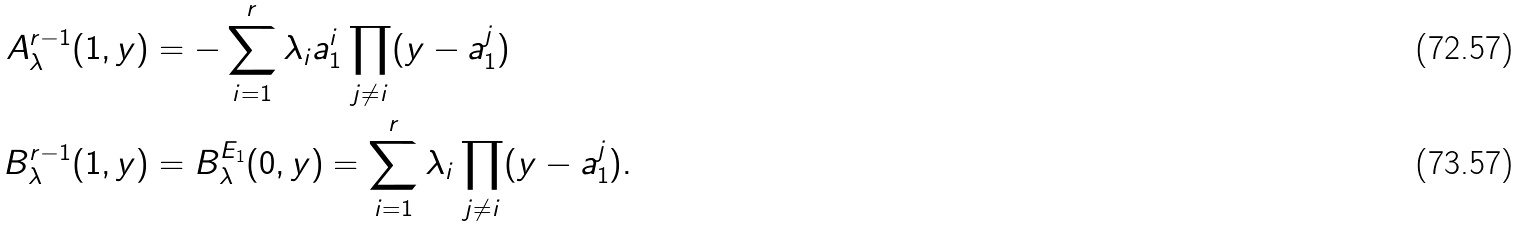Convert formula to latex. <formula><loc_0><loc_0><loc_500><loc_500>A _ { \lambda } ^ { r - 1 } ( 1 , y ) & = - \sum _ { i = 1 } ^ { r } \lambda _ { i } a _ { 1 } ^ { i } \prod _ { j \neq i } ( y - a _ { 1 } ^ { j } ) \\ B _ { \lambda } ^ { r - 1 } ( 1 , y ) & = B _ { \lambda } ^ { E _ { 1 } } ( 0 , y ) = \sum _ { i = 1 } ^ { r } \lambda _ { i } \prod _ { j \neq i } ( y - a _ { 1 } ^ { j } ) .</formula> 